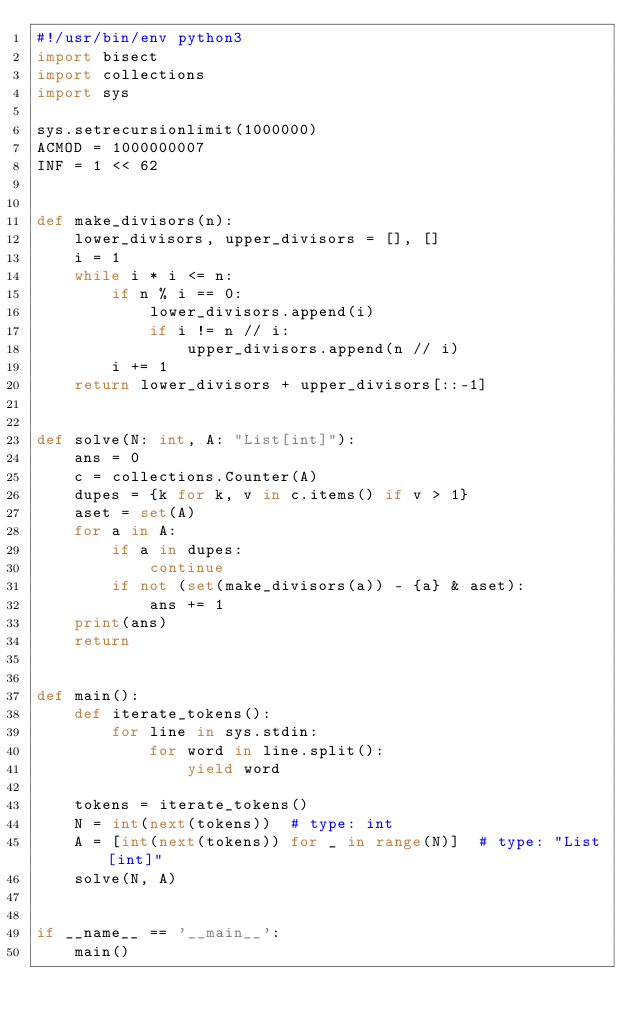Convert code to text. <code><loc_0><loc_0><loc_500><loc_500><_Python_>#!/usr/bin/env python3
import bisect
import collections
import sys

sys.setrecursionlimit(1000000)
ACMOD = 1000000007
INF = 1 << 62


def make_divisors(n):
    lower_divisors, upper_divisors = [], []
    i = 1
    while i * i <= n:
        if n % i == 0:
            lower_divisors.append(i)
            if i != n // i:
                upper_divisors.append(n // i)
        i += 1
    return lower_divisors + upper_divisors[::-1]


def solve(N: int, A: "List[int]"):
    ans = 0
    c = collections.Counter(A)
    dupes = {k for k, v in c.items() if v > 1}
    aset = set(A)
    for a in A:
        if a in dupes:
            continue
        if not (set(make_divisors(a)) - {a} & aset):
            ans += 1
    print(ans)
    return


def main():
    def iterate_tokens():
        for line in sys.stdin:
            for word in line.split():
                yield word

    tokens = iterate_tokens()
    N = int(next(tokens))  # type: int
    A = [int(next(tokens)) for _ in range(N)]  # type: "List[int]"
    solve(N, A)


if __name__ == '__main__':
    main()
</code> 